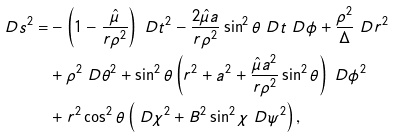<formula> <loc_0><loc_0><loc_500><loc_500>\ D s ^ { 2 } = & - \left ( 1 - \frac { \hat { \mu } } { r \rho ^ { 2 } } \right ) \ D t ^ { 2 } - \frac { 2 \hat { \mu } a } { r \rho ^ { 2 } } \sin ^ { 2 } \theta \ D t \ D \phi + \frac { \rho ^ { 2 } } { \Delta } \ D r ^ { 2 } \\ & + \rho ^ { 2 } \ D \theta ^ { 2 } + \sin ^ { 2 } \theta \left ( r ^ { 2 } + a ^ { 2 } + \frac { \hat { \mu } a ^ { 2 } } { r \rho ^ { 2 } } \sin ^ { 2 } \theta \right ) \ D \phi ^ { 2 } \\ & + r ^ { 2 } \cos ^ { 2 } \theta \left ( \ D \chi ^ { 2 } + B ^ { 2 } \sin ^ { 2 } \chi \ D \psi ^ { 2 } \right ) ,</formula> 